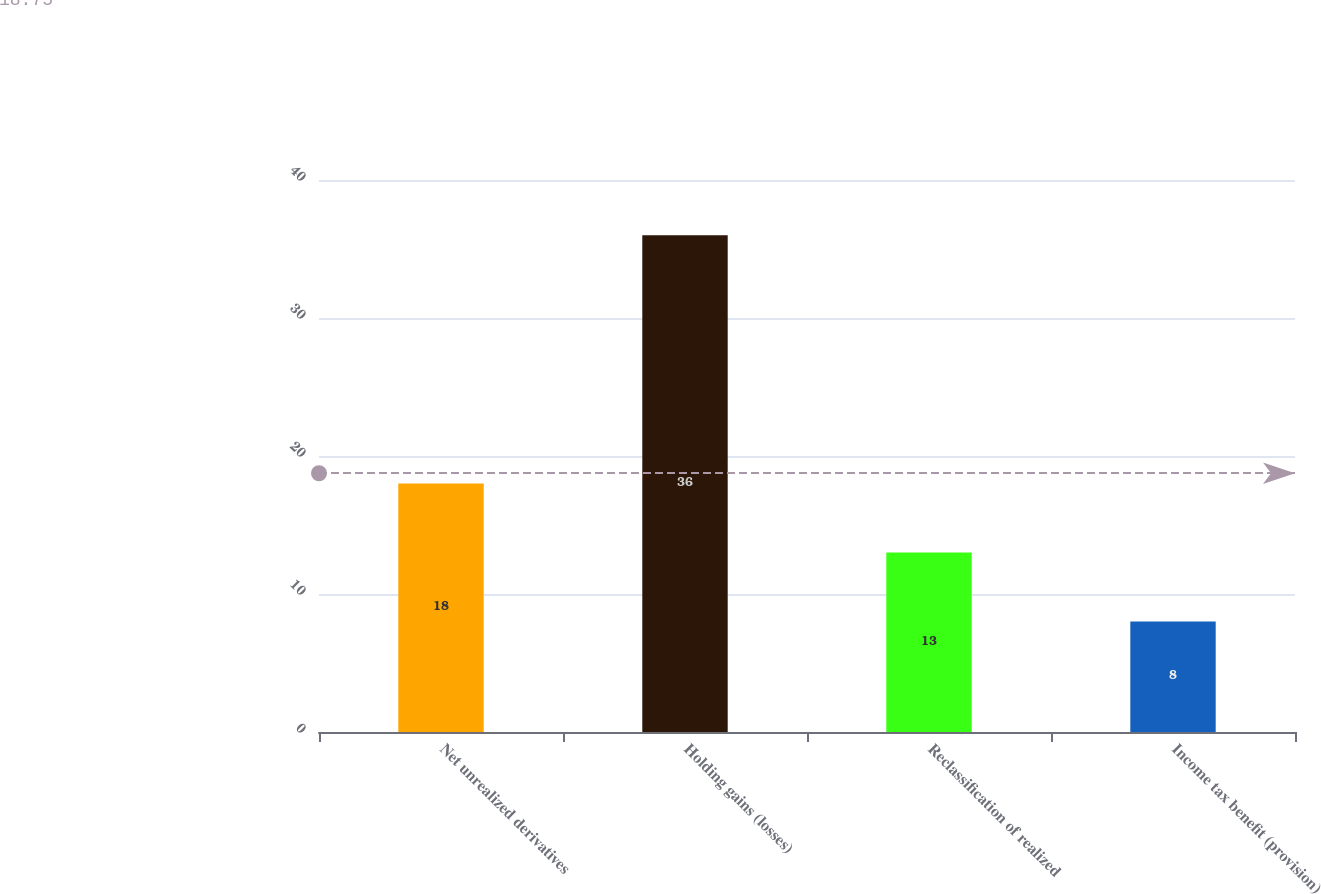Convert chart to OTSL. <chart><loc_0><loc_0><loc_500><loc_500><bar_chart><fcel>Net unrealized derivatives<fcel>Holding gains (losses)<fcel>Reclassification of realized<fcel>Income tax benefit (provision)<nl><fcel>18<fcel>36<fcel>13<fcel>8<nl></chart> 